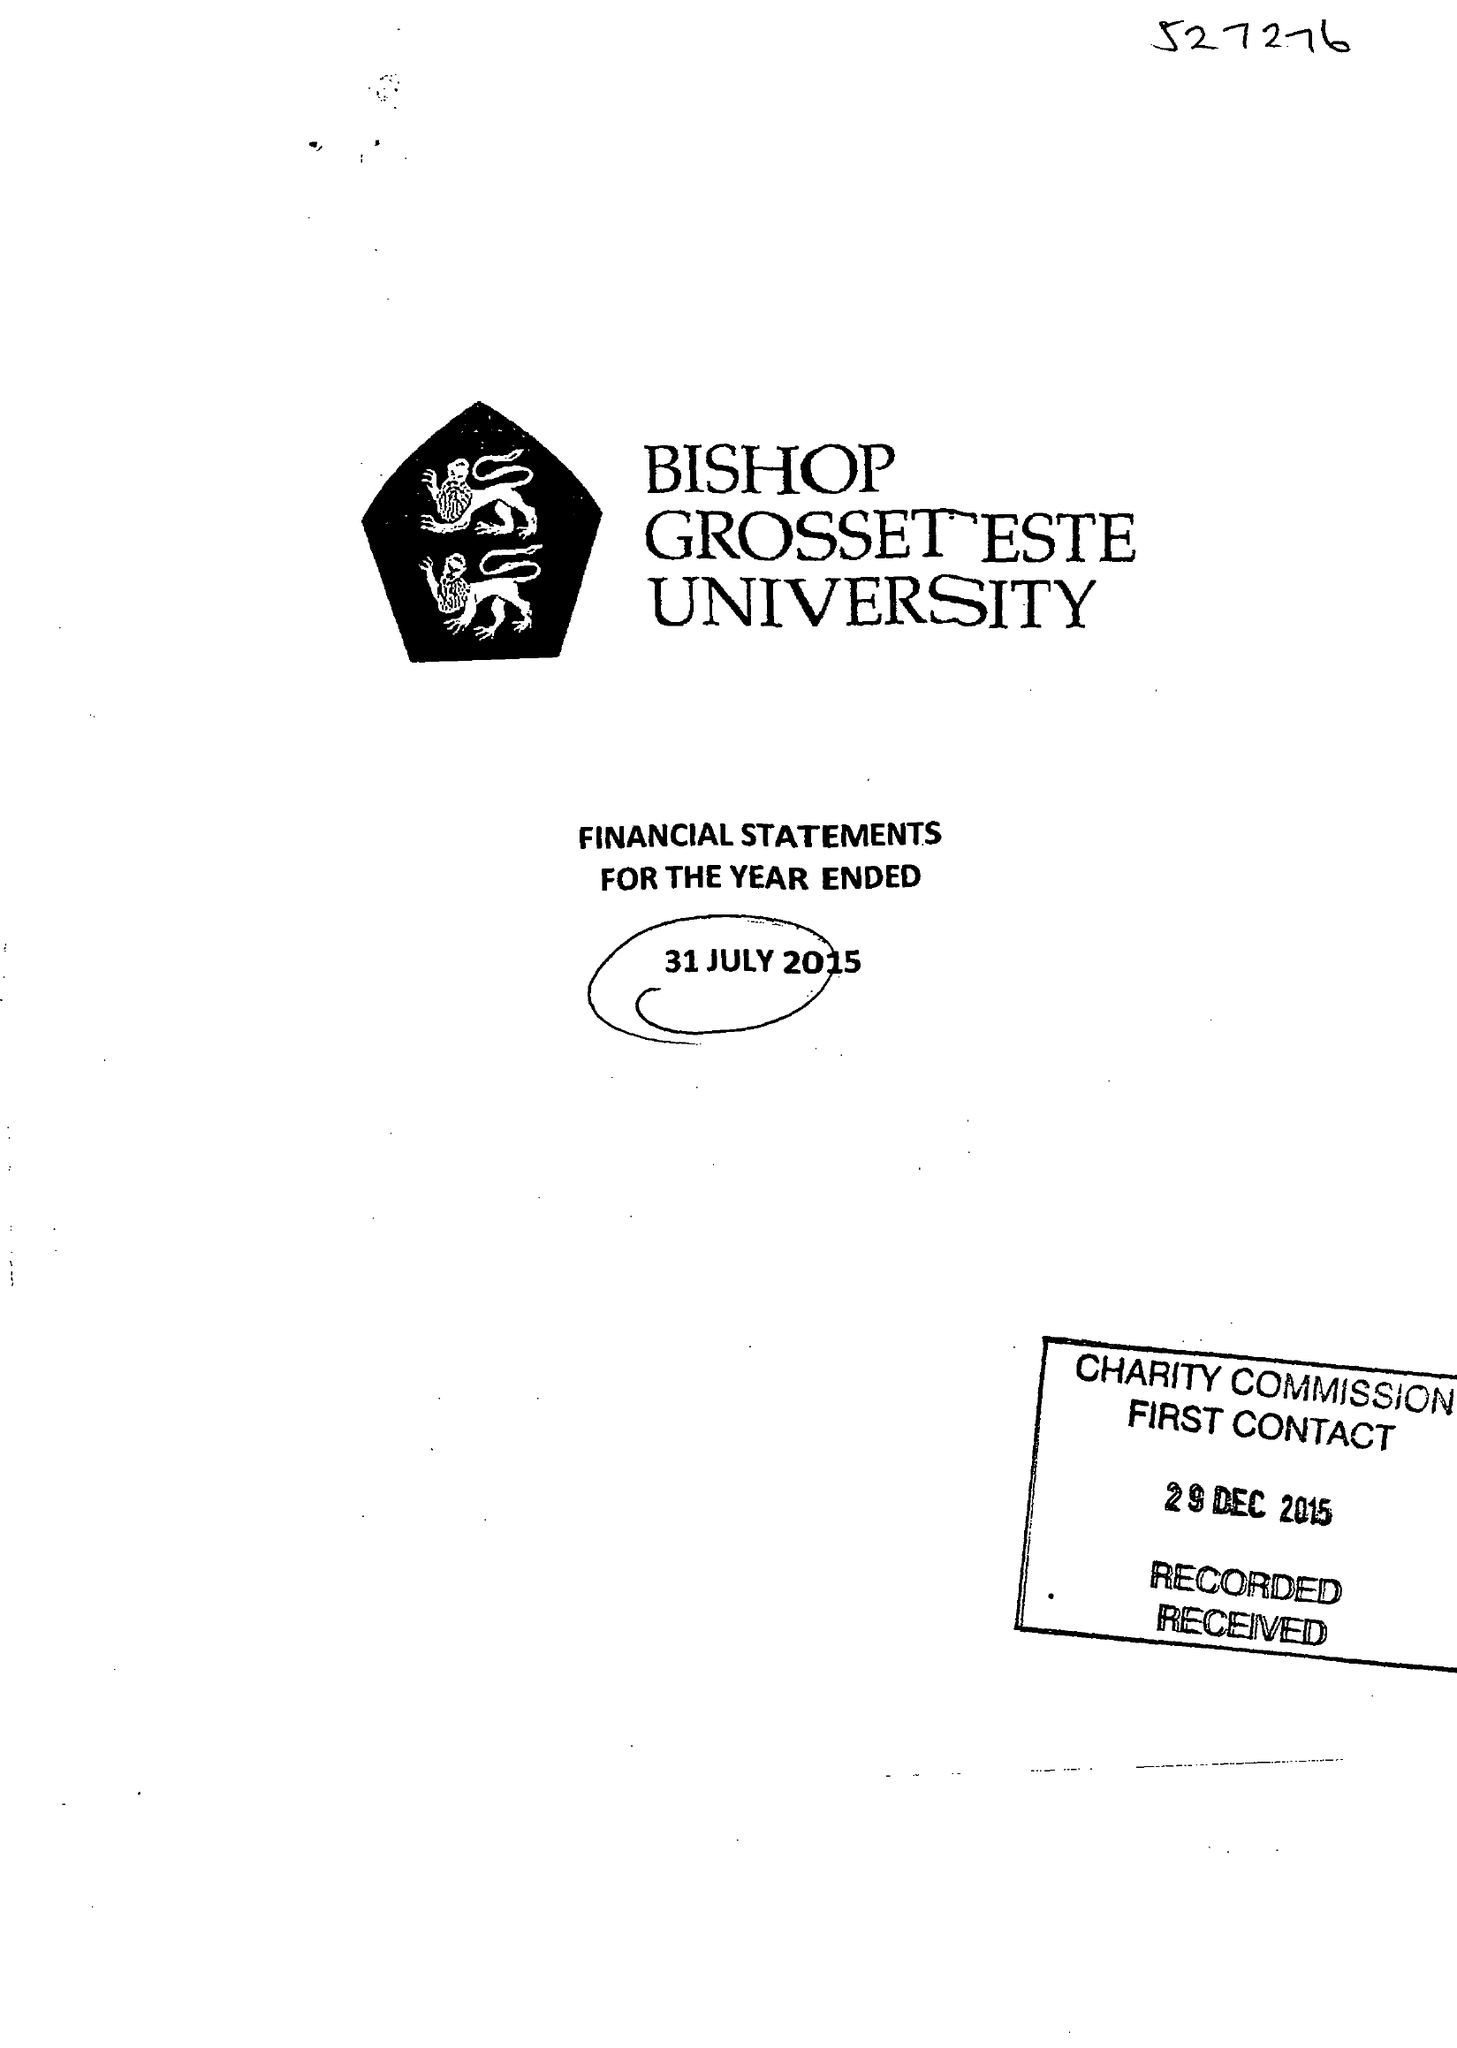What is the value for the address__post_town?
Answer the question using a single word or phrase. LINCOLN 